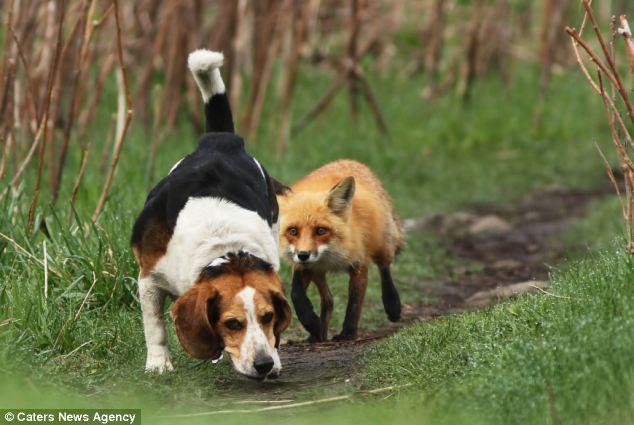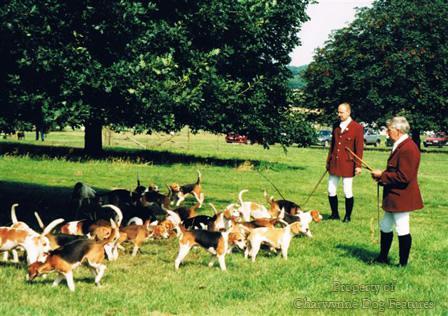The first image is the image on the left, the second image is the image on the right. Considering the images on both sides, is "There are no people in one of the images." valid? Answer yes or no. Yes. The first image is the image on the left, the second image is the image on the right. Evaluate the accuracy of this statement regarding the images: "In one image, at least two people wearing hunting jackets with white breeches and black boots are on foot with a pack of hunting dogs.". Is it true? Answer yes or no. Yes. 